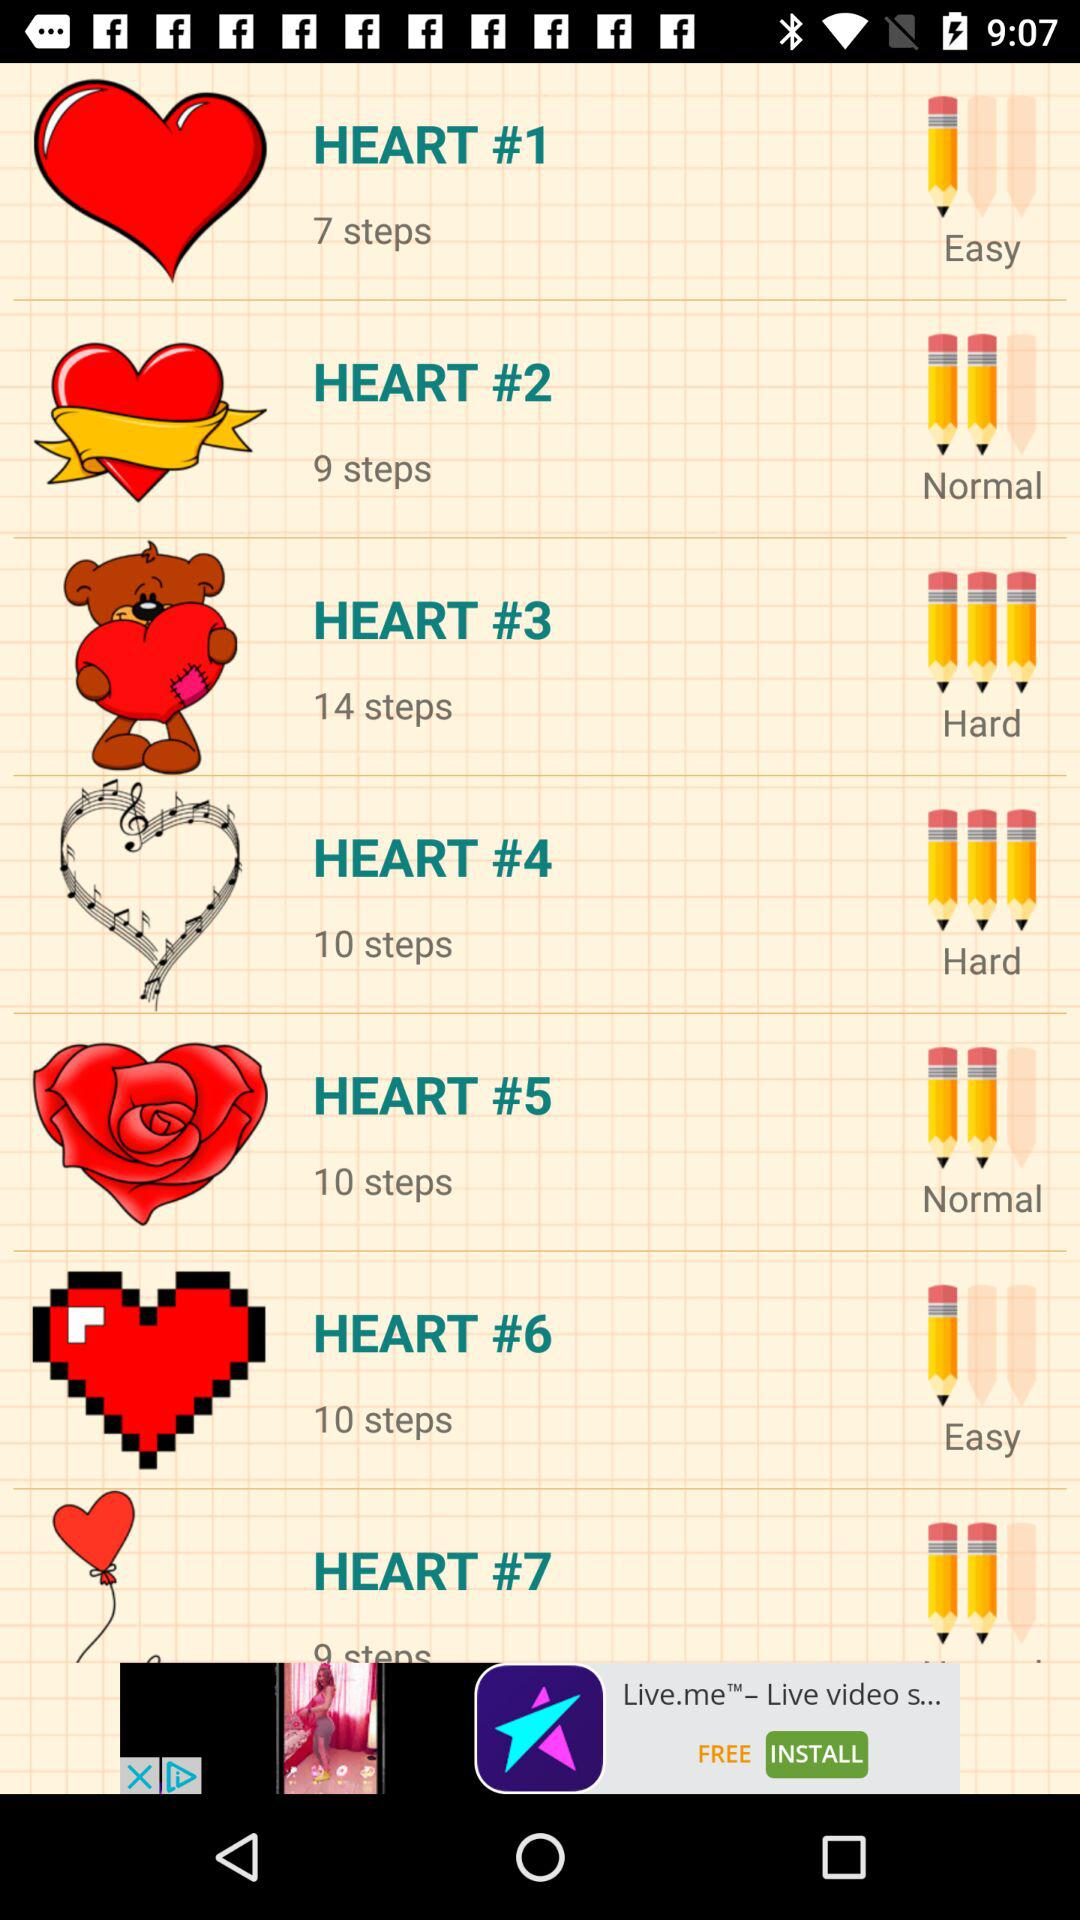What is the difficulty level for "HEART #4"? The difficulty level for "HEART #4" is hard. 